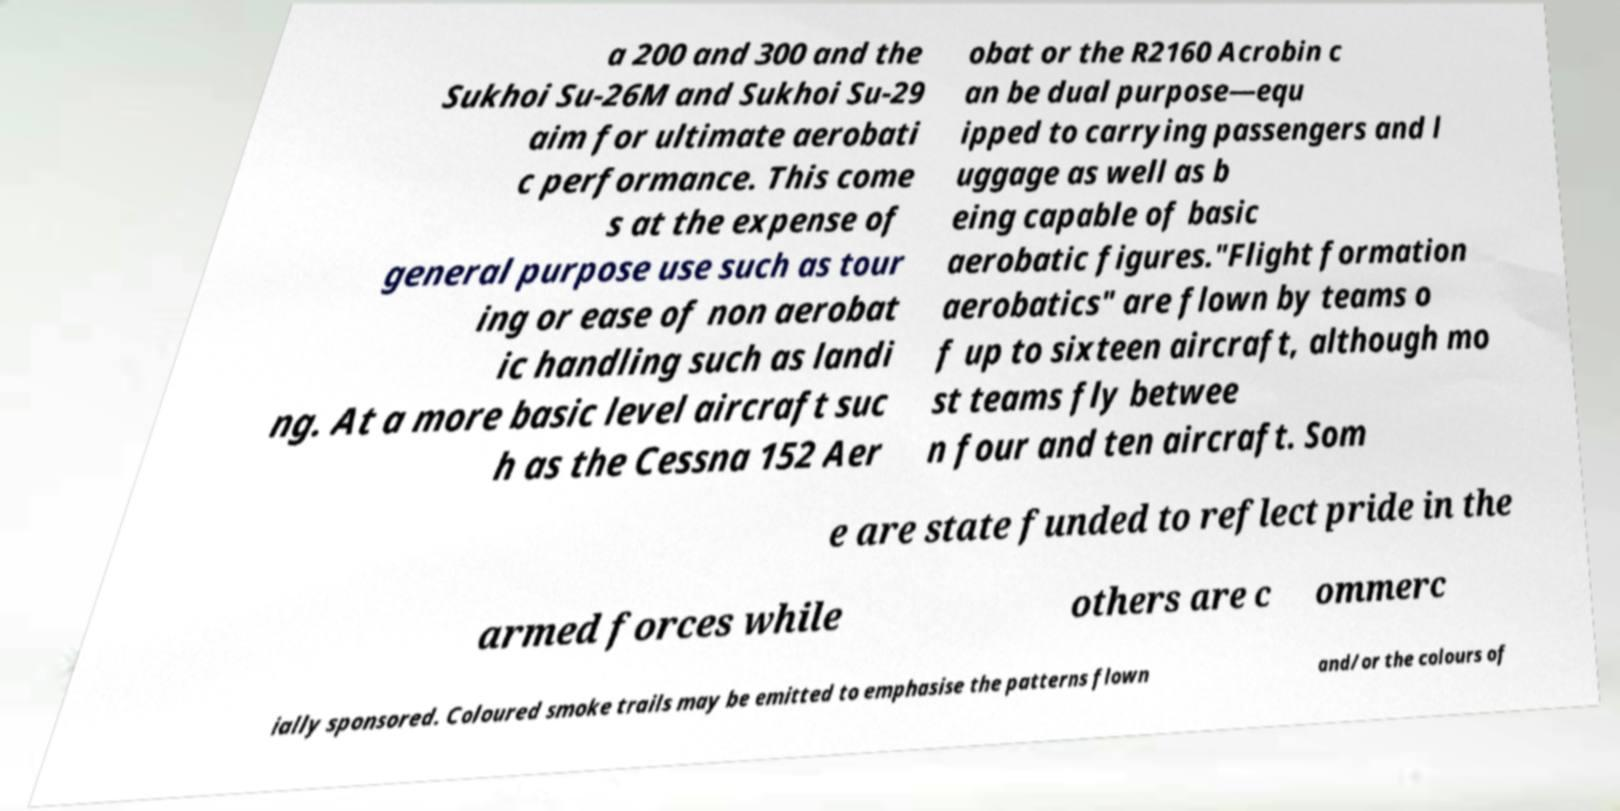I need the written content from this picture converted into text. Can you do that? a 200 and 300 and the Sukhoi Su-26M and Sukhoi Su-29 aim for ultimate aerobati c performance. This come s at the expense of general purpose use such as tour ing or ease of non aerobat ic handling such as landi ng. At a more basic level aircraft suc h as the Cessna 152 Aer obat or the R2160 Acrobin c an be dual purpose—equ ipped to carrying passengers and l uggage as well as b eing capable of basic aerobatic figures."Flight formation aerobatics" are flown by teams o f up to sixteen aircraft, although mo st teams fly betwee n four and ten aircraft. Som e are state funded to reflect pride in the armed forces while others are c ommerc ially sponsored. Coloured smoke trails may be emitted to emphasise the patterns flown and/or the colours of 